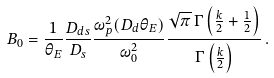Convert formula to latex. <formula><loc_0><loc_0><loc_500><loc_500>B _ { 0 } = \frac { 1 } { \theta _ { E } } \frac { D _ { d s } } { D _ { s } } \frac { \omega _ { p } ^ { 2 } ( D _ { d } \theta _ { E } ) } { \omega _ { 0 } ^ { 2 } } \frac { \sqrt { \pi } \, \Gamma \left ( \frac { k } { 2 } + \frac { 1 } { 2 } \right ) } { \Gamma \left ( \frac { k } { 2 } \right ) } \, .</formula> 